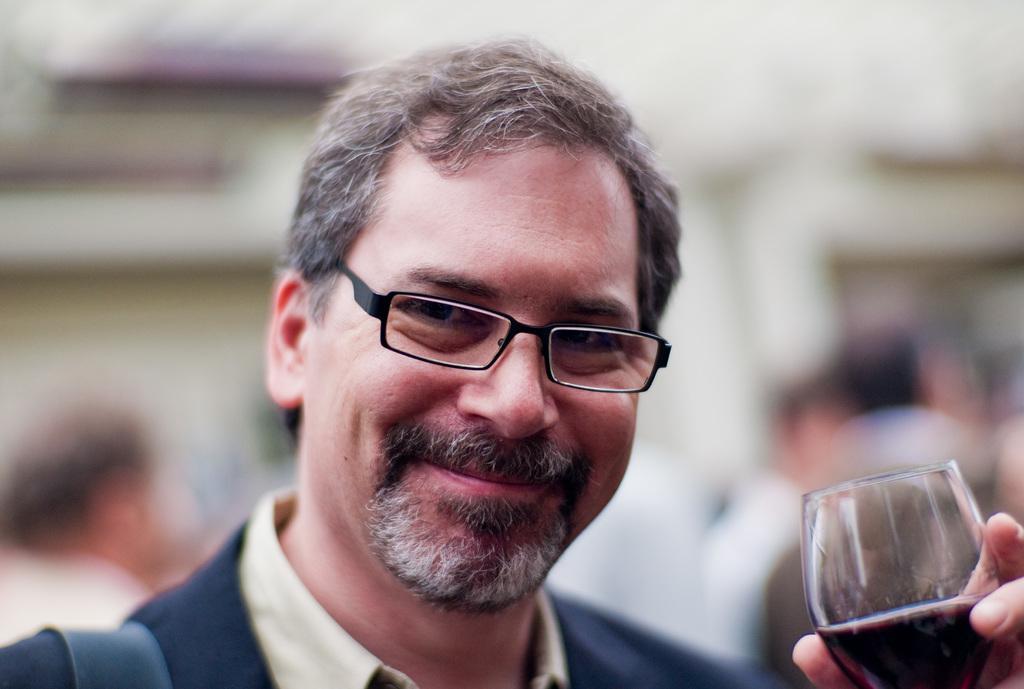In one or two sentences, can you explain what this image depicts? In this picture, we see a man who is wearing blue color shirt, is holding a glass containing some liquid in his hands and he is even wearing spectacles. He is smiling. 